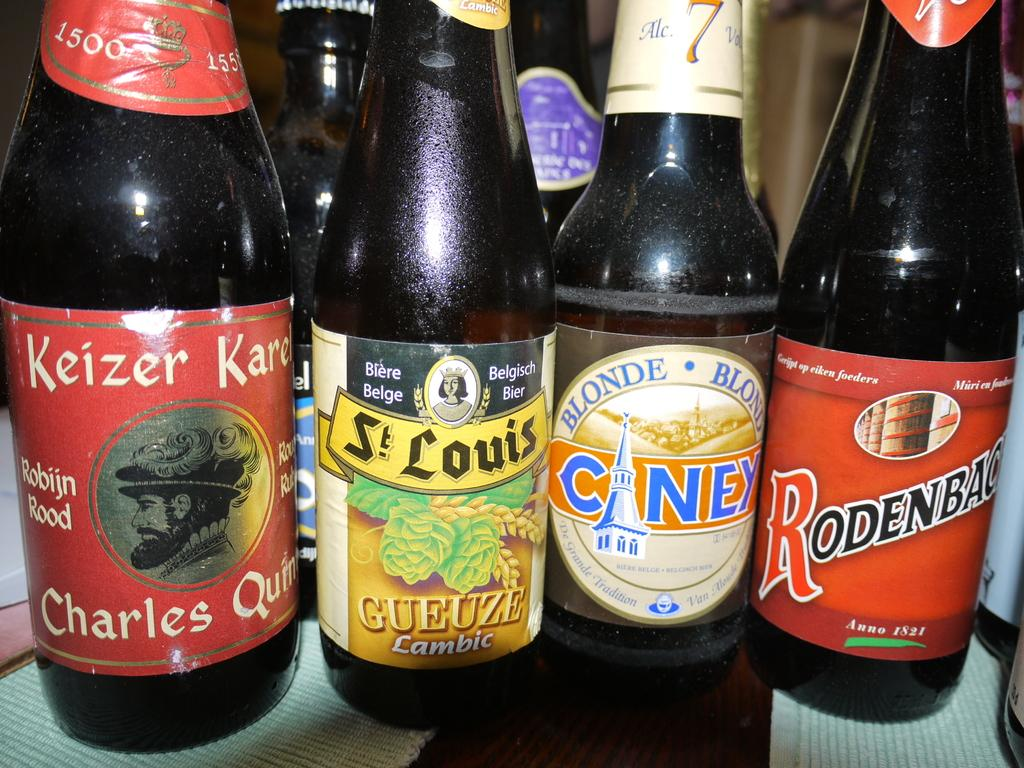<image>
Create a compact narrative representing the image presented. A bottle of beer with the word Gueuze on the label sits near other bottles on a table. 